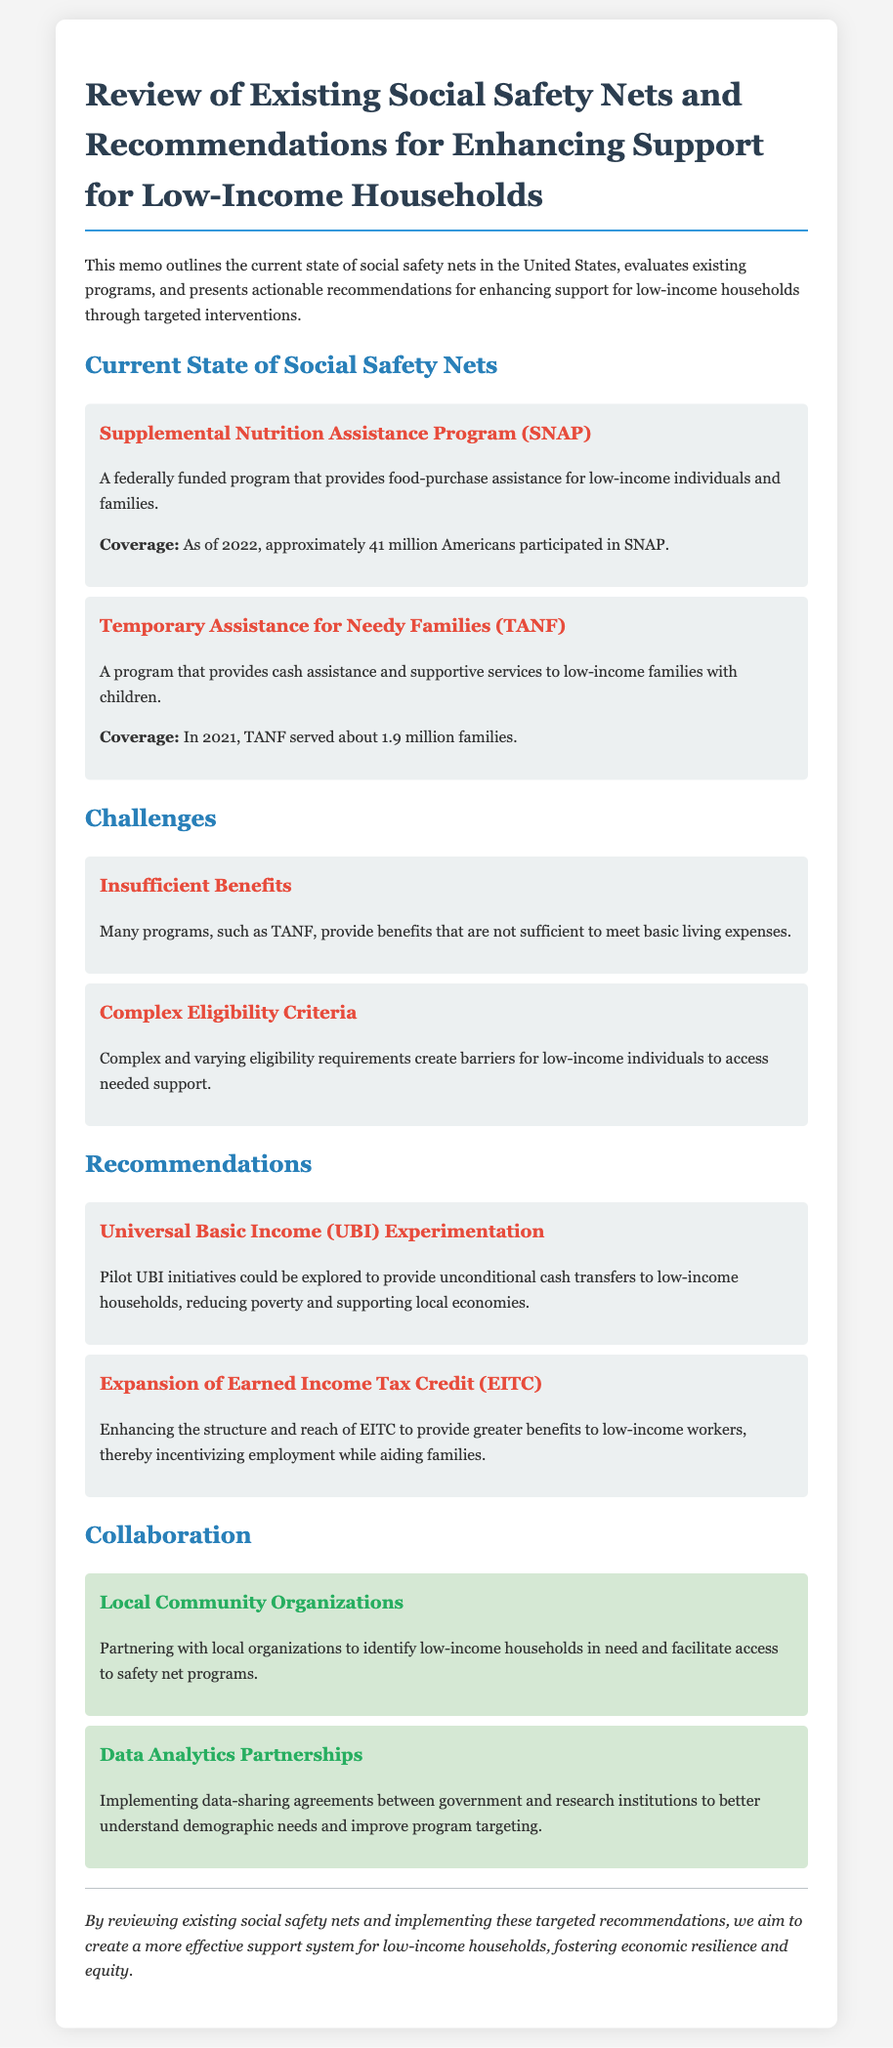What is the main focus of this memo? The memo outlines the review of social safety nets and presents recommendations for enhancing support for low-income households.
Answer: Review of existing social safety nets and recommendations for enhancing support for low-income households How many Americans participated in SNAP as of 2022? The document states that approximately 41 million Americans participated in SNAP.
Answer: 41 million What is the coverage of TANF in 2021? The memo mentions that TANF served about 1.9 million families in 2021.
Answer: 1.9 million What challenge is posed by insufficient benefits? The document indicates that programs like TANF do not provide benefits sufficient to meet basic living expenses.
Answer: Basic living expenses What type of experimentation is recommended for low-income households? The memo suggests that pilot UBI initiatives be explored for low-income households.
Answer: Universal Basic Income Who should be partnered with to facilitate access to safety net programs? The memo recommends partnering with local community organizations to help identify low-income households.
Answer: Local community organizations What is one way to enhance the Earned Income Tax Credit? The document states that enhancing the structure and reach of the EITC would provide greater benefits to low-income workers.
Answer: Greater benefits What type of partnerships are suggested for better understanding demographic needs? The memo discusses implementing data-sharing agreements between government and research institutions.
Answer: Data analytics partnerships 